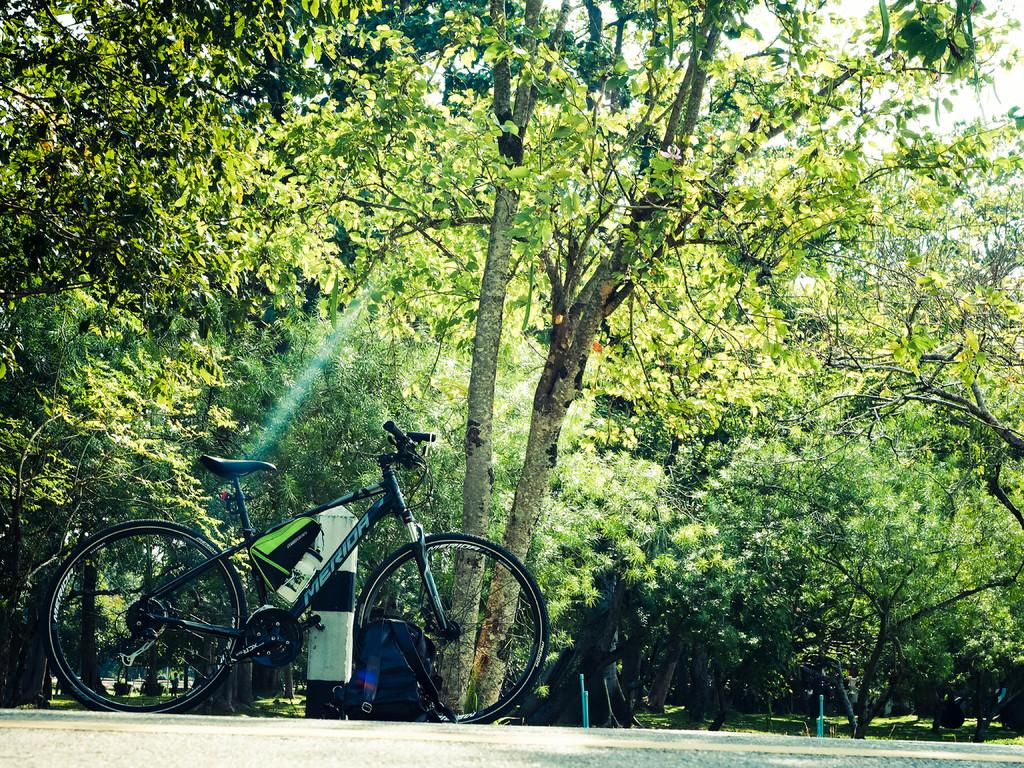What is the main object in the image? There is a bicycle in the image. What else can be seen on the ground in the image? Two bags are present on the road in the image. What can be seen in the distance in the image? There are trees visible in the background of the image. Where is the mother holding the doll near the dock in the image? There is no mother, doll, or dock present in the image. 